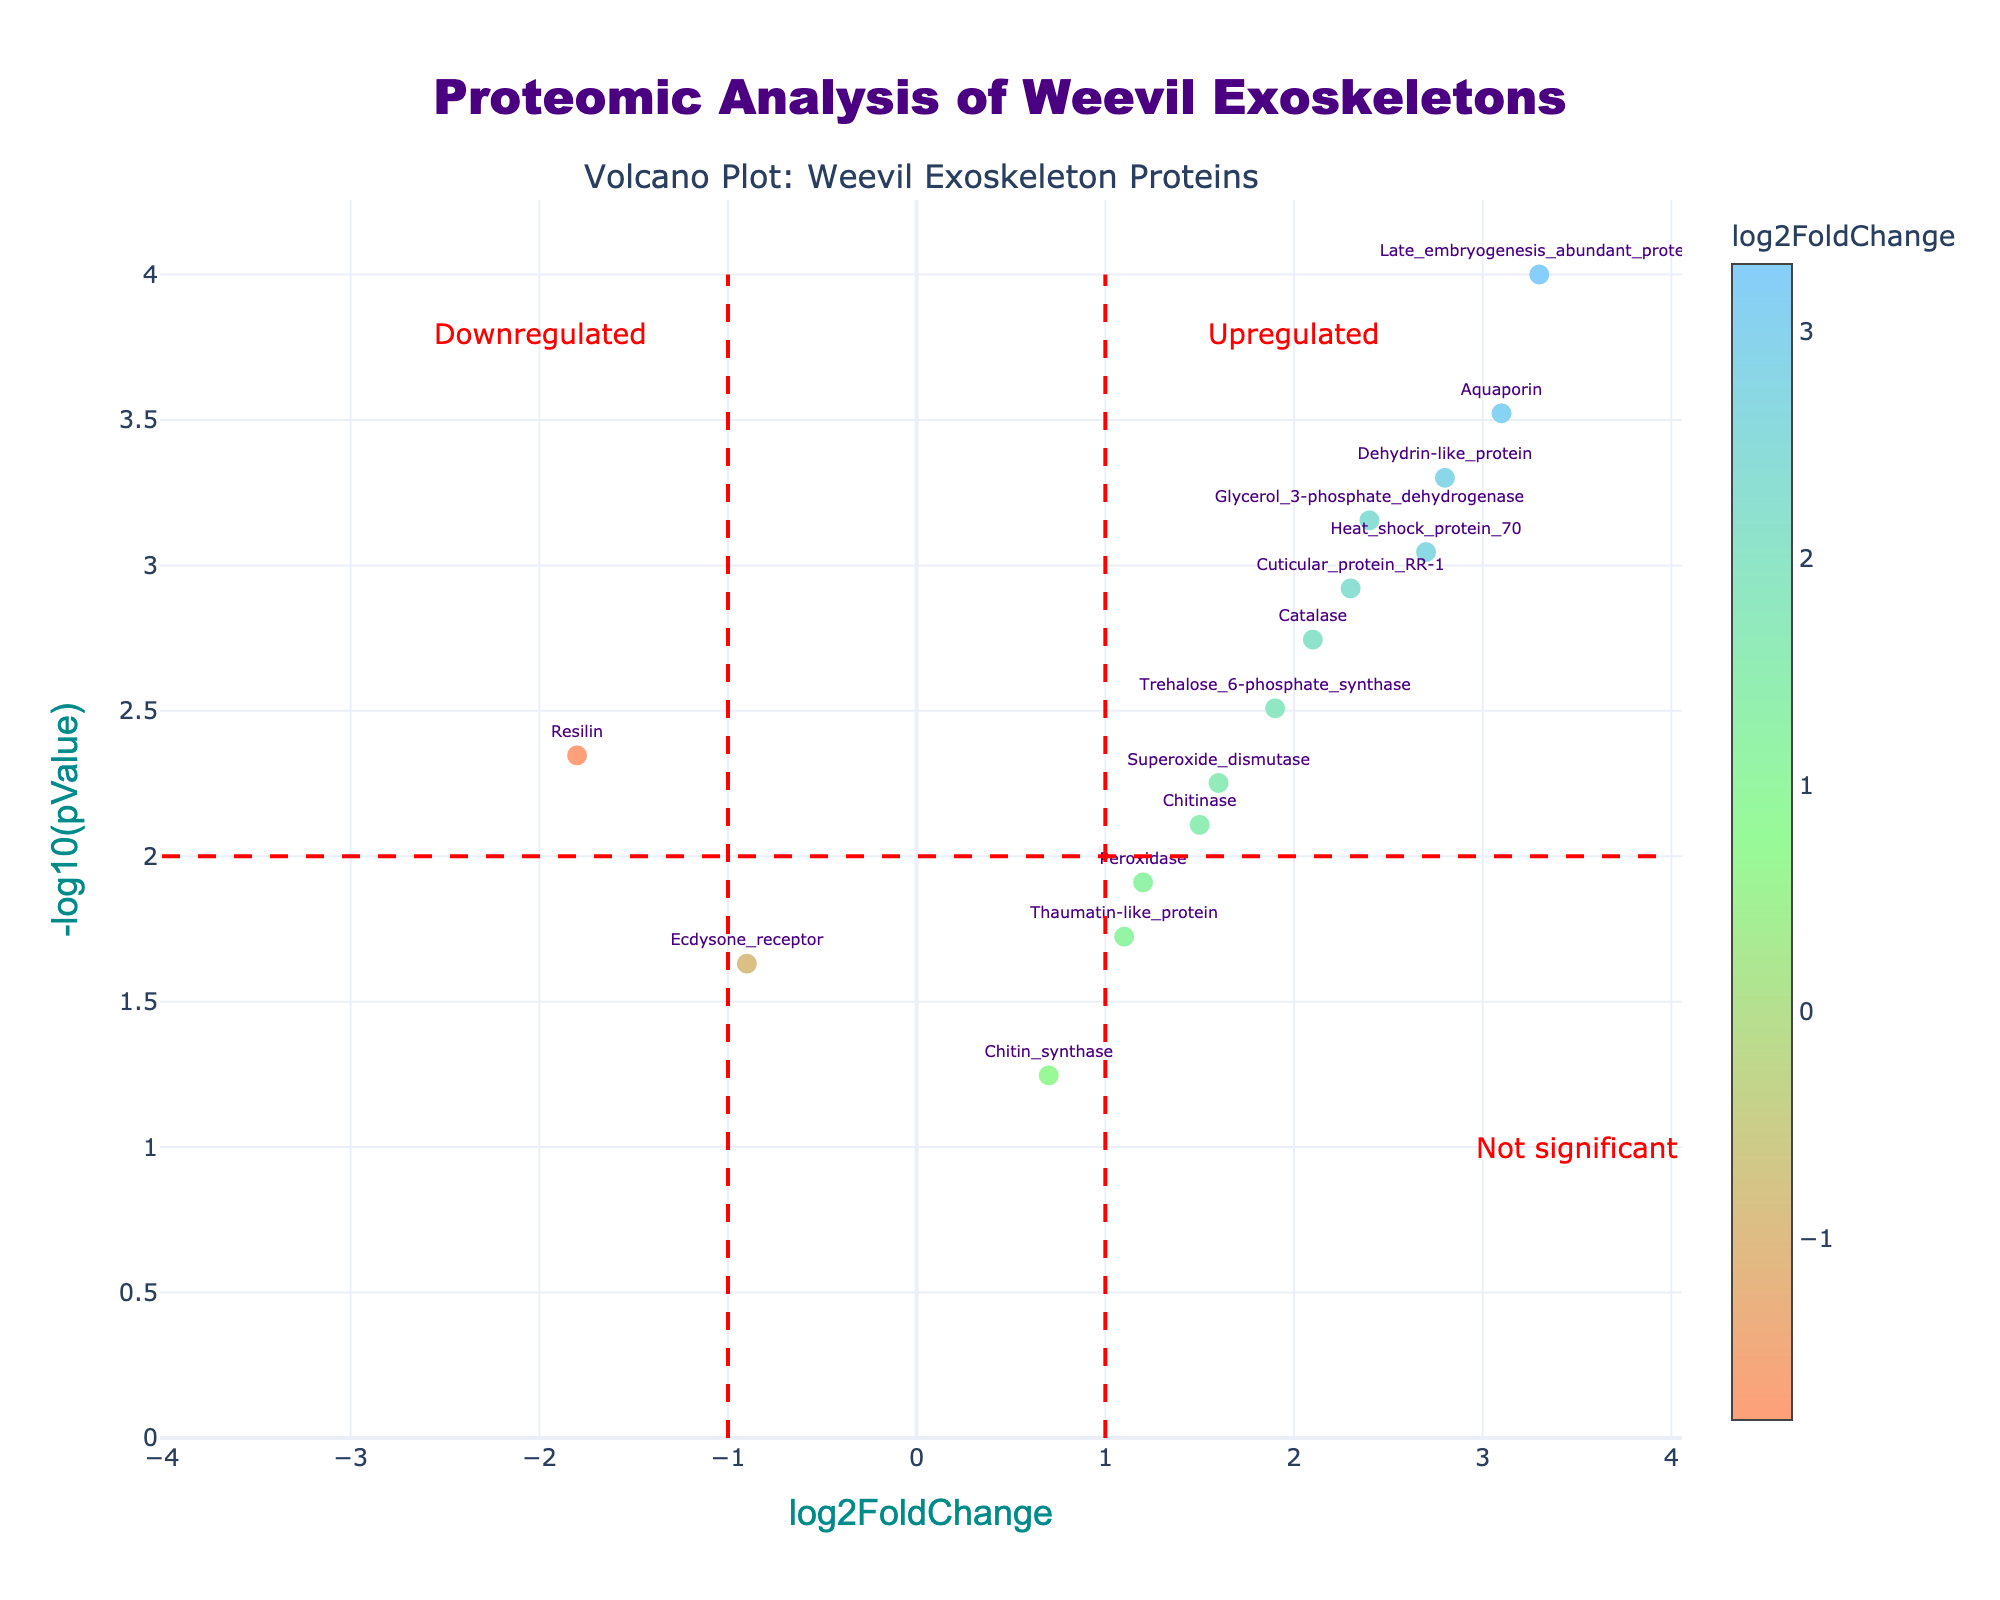What is the title of the plot? The title of the plot is usually displayed at the top. In this case, the title is "Proteomic Analysis of Weevil Exoskeletons."
Answer: Proteomic Analysis of Weevil Exoskeletons Which protein has the highest log2FoldChange? Look at the x-axis values and find the protein with the highest value. This corresponds to "Late_embryogenesis_abundant_protein" with a log2FoldChange of 3.3.
Answer: Late_embryogenesis_abundant_protein What do the red dashed lines in the plot represent? The red dashed lines at log2FoldChange of -1 and 1 represent the thresholds for significant upregulation and downregulation. The horizontal red dashed line at -log10(pValue) of 2 represents the threshold for statistical significance.
Answer: Thresholds for significant upregulation and downregulation and statistical significance How many proteins are considered significantly upregulated? Count the number of data points that are to the right of the vertical red dashed line at log2FoldChange of 1 and above the horizontal red dashed line at -log10(pValue) of 2. There are 7 such proteins.
Answer: 7 Which proteins are upregulated and have a log2FoldChange greater than 2.5? Identify points to the right of log2FoldChange of 2.5 and above the significance threshold. They are "Aquaporin", "Heat_shock_protein_70", "Dehydrin-like_protein", and "Late_embryogenesis_abundant_protein."
Answer: Aquaporin, Heat_shock_protein_70, Dehydrin-like_protein, Late_embryogenesis_abundant_protein How does the log2FoldChange of "Chitinase" compare to "Catalase"? Find the log2FoldChange values for "Chitinase" and "Catalase", which are 1.5 and 2.1, respectively, and compare. "Catalase" has a higher log2FoldChange than "Chitinase".
Answer: Catalase has a higher log2FoldChange than Chitinase Which protein has the lowest p-value, indicating the highest statistical significance, and what is its log2FoldChange? Look for the data point with the highest -log10(pValue) value and note its corresponding protein and log2FoldChange. "Late_embryogenesis_abundant_protein" has the lowest p-value and a log2FoldChange of 3.3.
Answer: Late_embryogenesis_abundant_protein, 3.3 Which proteins are downregulated but not statistically significant? Find proteins with log2FoldChange less than -1, but below the significance threshold line (below -log10(pValue) of 2). The protein "Ecdysone_receptor" fits this criteria.
Answer: Ecdysone_receptor What's the overall trend in the relationship between log2FoldChange and statistical significance for upregulated proteins? Upregulated proteins with higher log2FoldChange tend to have lower p-values (higher statistical significance), shown by most significant proteins being to the right of the plot and above the significance threshold line.
Answer: Higher log2FoldChange tends to correlate with higher statistical significance 